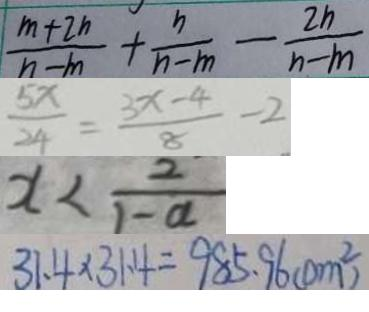Convert formula to latex. <formula><loc_0><loc_0><loc_500><loc_500>\frac { m + 2 n } { n - m } + \frac { n } { n - m } - \frac { 2 n } { n - m } 
 \frac { 5 x } { 2 4 } = \frac { 3 x - 4 } { 8 } - 2 
 x < \frac { 2 } { 1 - a } 
 3 1 . 4 \times 3 1 . 4 = 9 8 5 . 9 6 ( c m ^ { 2 } )</formula> 